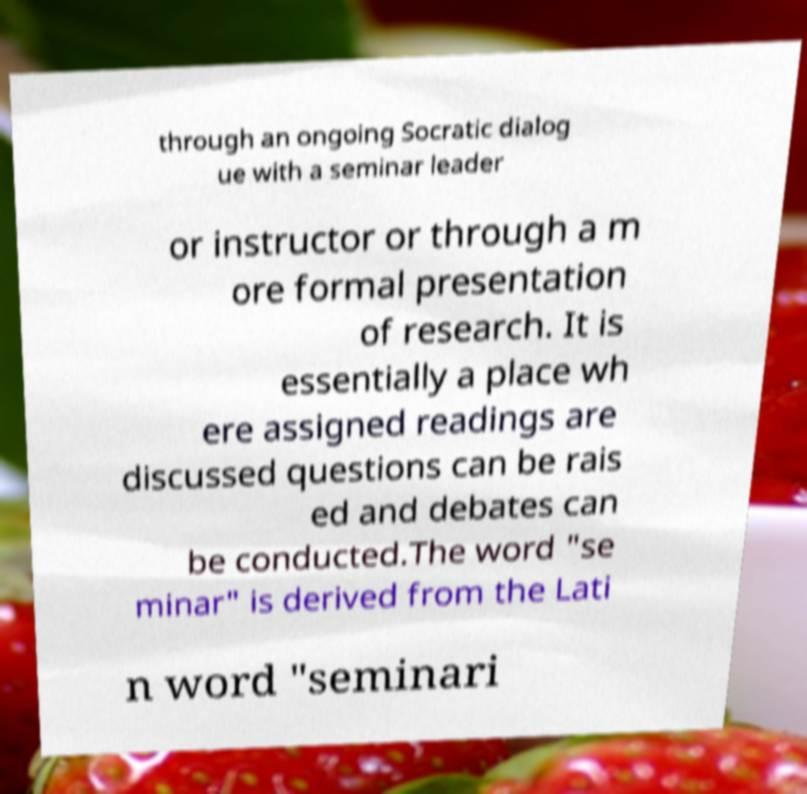What messages or text are displayed in this image? I need them in a readable, typed format. through an ongoing Socratic dialog ue with a seminar leader or instructor or through a m ore formal presentation of research. It is essentially a place wh ere assigned readings are discussed questions can be rais ed and debates can be conducted.The word "se minar" is derived from the Lati n word "seminari 